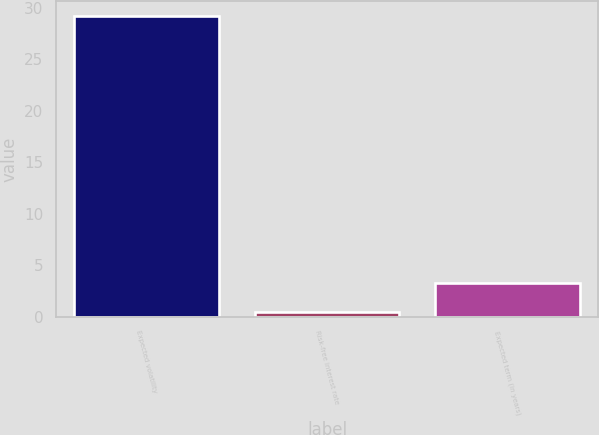Convert chart to OTSL. <chart><loc_0><loc_0><loc_500><loc_500><bar_chart><fcel>Expected volatility<fcel>Risk-free interest rate<fcel>Expected term (in years)<nl><fcel>29.18<fcel>0.42<fcel>3.3<nl></chart> 